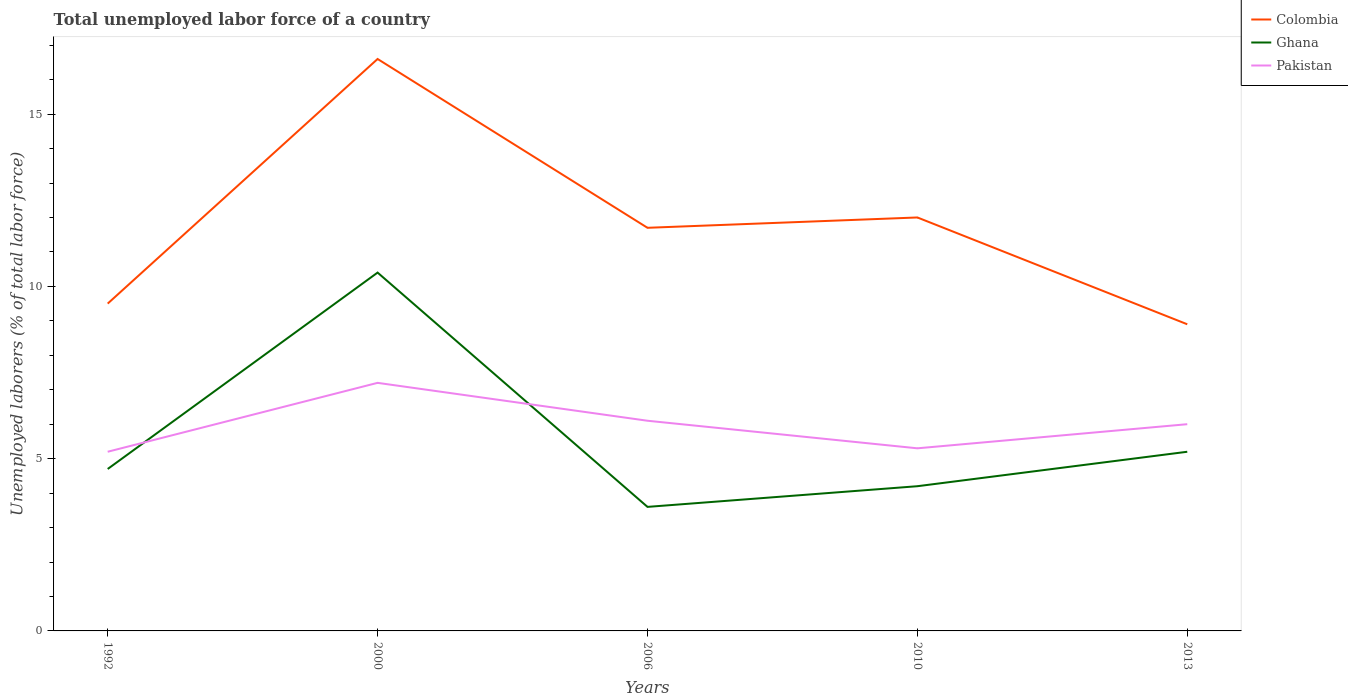How many different coloured lines are there?
Your answer should be compact. 3. Across all years, what is the maximum total unemployed labor force in Ghana?
Provide a succinct answer. 3.6. In which year was the total unemployed labor force in Pakistan maximum?
Offer a very short reply. 1992. What is the total total unemployed labor force in Colombia in the graph?
Keep it short and to the point. 7.7. What is the difference between the highest and the second highest total unemployed labor force in Ghana?
Ensure brevity in your answer.  6.8. Is the total unemployed labor force in Pakistan strictly greater than the total unemployed labor force in Colombia over the years?
Make the answer very short. Yes. How many lines are there?
Provide a succinct answer. 3. How many legend labels are there?
Your answer should be very brief. 3. How are the legend labels stacked?
Provide a short and direct response. Vertical. What is the title of the graph?
Ensure brevity in your answer.  Total unemployed labor force of a country. Does "West Bank and Gaza" appear as one of the legend labels in the graph?
Ensure brevity in your answer.  No. What is the label or title of the Y-axis?
Give a very brief answer. Unemployed laborers (% of total labor force). What is the Unemployed laborers (% of total labor force) of Colombia in 1992?
Provide a succinct answer. 9.5. What is the Unemployed laborers (% of total labor force) in Ghana in 1992?
Your answer should be compact. 4.7. What is the Unemployed laborers (% of total labor force) in Pakistan in 1992?
Offer a very short reply. 5.2. What is the Unemployed laborers (% of total labor force) of Colombia in 2000?
Your answer should be very brief. 16.6. What is the Unemployed laborers (% of total labor force) of Ghana in 2000?
Your answer should be very brief. 10.4. What is the Unemployed laborers (% of total labor force) of Pakistan in 2000?
Keep it short and to the point. 7.2. What is the Unemployed laborers (% of total labor force) of Colombia in 2006?
Your answer should be very brief. 11.7. What is the Unemployed laborers (% of total labor force) of Ghana in 2006?
Provide a succinct answer. 3.6. What is the Unemployed laborers (% of total labor force) in Pakistan in 2006?
Keep it short and to the point. 6.1. What is the Unemployed laborers (% of total labor force) in Ghana in 2010?
Your answer should be very brief. 4.2. What is the Unemployed laborers (% of total labor force) in Pakistan in 2010?
Your answer should be very brief. 5.3. What is the Unemployed laborers (% of total labor force) in Colombia in 2013?
Ensure brevity in your answer.  8.9. What is the Unemployed laborers (% of total labor force) of Ghana in 2013?
Keep it short and to the point. 5.2. Across all years, what is the maximum Unemployed laborers (% of total labor force) in Colombia?
Give a very brief answer. 16.6. Across all years, what is the maximum Unemployed laborers (% of total labor force) of Ghana?
Your answer should be very brief. 10.4. Across all years, what is the maximum Unemployed laborers (% of total labor force) in Pakistan?
Your answer should be very brief. 7.2. Across all years, what is the minimum Unemployed laborers (% of total labor force) in Colombia?
Provide a succinct answer. 8.9. Across all years, what is the minimum Unemployed laborers (% of total labor force) of Ghana?
Keep it short and to the point. 3.6. Across all years, what is the minimum Unemployed laborers (% of total labor force) of Pakistan?
Make the answer very short. 5.2. What is the total Unemployed laborers (% of total labor force) in Colombia in the graph?
Your answer should be very brief. 58.7. What is the total Unemployed laborers (% of total labor force) of Ghana in the graph?
Ensure brevity in your answer.  28.1. What is the total Unemployed laborers (% of total labor force) in Pakistan in the graph?
Provide a succinct answer. 29.8. What is the difference between the Unemployed laborers (% of total labor force) of Pakistan in 1992 and that in 2000?
Make the answer very short. -2. What is the difference between the Unemployed laborers (% of total labor force) of Ghana in 1992 and that in 2006?
Give a very brief answer. 1.1. What is the difference between the Unemployed laborers (% of total labor force) in Pakistan in 1992 and that in 2006?
Give a very brief answer. -0.9. What is the difference between the Unemployed laborers (% of total labor force) in Pakistan in 1992 and that in 2013?
Make the answer very short. -0.8. What is the difference between the Unemployed laborers (% of total labor force) of Ghana in 2000 and that in 2006?
Keep it short and to the point. 6.8. What is the difference between the Unemployed laborers (% of total labor force) in Pakistan in 2000 and that in 2006?
Make the answer very short. 1.1. What is the difference between the Unemployed laborers (% of total labor force) in Colombia in 2000 and that in 2010?
Give a very brief answer. 4.6. What is the difference between the Unemployed laborers (% of total labor force) in Ghana in 2000 and that in 2010?
Provide a succinct answer. 6.2. What is the difference between the Unemployed laborers (% of total labor force) of Pakistan in 2000 and that in 2010?
Your response must be concise. 1.9. What is the difference between the Unemployed laborers (% of total labor force) in Colombia in 2000 and that in 2013?
Give a very brief answer. 7.7. What is the difference between the Unemployed laborers (% of total labor force) in Colombia in 2006 and that in 2010?
Offer a terse response. -0.3. What is the difference between the Unemployed laborers (% of total labor force) in Ghana in 2006 and that in 2010?
Make the answer very short. -0.6. What is the difference between the Unemployed laborers (% of total labor force) in Pakistan in 2006 and that in 2010?
Offer a terse response. 0.8. What is the difference between the Unemployed laborers (% of total labor force) of Colombia in 2006 and that in 2013?
Offer a very short reply. 2.8. What is the difference between the Unemployed laborers (% of total labor force) in Ghana in 2006 and that in 2013?
Provide a succinct answer. -1.6. What is the difference between the Unemployed laborers (% of total labor force) in Pakistan in 2006 and that in 2013?
Offer a terse response. 0.1. What is the difference between the Unemployed laborers (% of total labor force) in Ghana in 2010 and that in 2013?
Provide a short and direct response. -1. What is the difference between the Unemployed laborers (% of total labor force) in Colombia in 1992 and the Unemployed laborers (% of total labor force) in Ghana in 2006?
Ensure brevity in your answer.  5.9. What is the difference between the Unemployed laborers (% of total labor force) of Colombia in 1992 and the Unemployed laborers (% of total labor force) of Pakistan in 2006?
Give a very brief answer. 3.4. What is the difference between the Unemployed laborers (% of total labor force) in Ghana in 1992 and the Unemployed laborers (% of total labor force) in Pakistan in 2006?
Make the answer very short. -1.4. What is the difference between the Unemployed laborers (% of total labor force) of Ghana in 1992 and the Unemployed laborers (% of total labor force) of Pakistan in 2010?
Provide a succinct answer. -0.6. What is the difference between the Unemployed laborers (% of total labor force) of Colombia in 1992 and the Unemployed laborers (% of total labor force) of Ghana in 2013?
Your response must be concise. 4.3. What is the difference between the Unemployed laborers (% of total labor force) in Ghana in 2000 and the Unemployed laborers (% of total labor force) in Pakistan in 2006?
Offer a very short reply. 4.3. What is the difference between the Unemployed laborers (% of total labor force) of Colombia in 2000 and the Unemployed laborers (% of total labor force) of Pakistan in 2010?
Your answer should be compact. 11.3. What is the difference between the Unemployed laborers (% of total labor force) in Ghana in 2000 and the Unemployed laborers (% of total labor force) in Pakistan in 2010?
Your answer should be compact. 5.1. What is the difference between the Unemployed laborers (% of total labor force) in Colombia in 2006 and the Unemployed laborers (% of total labor force) in Ghana in 2010?
Your answer should be very brief. 7.5. What is the difference between the Unemployed laborers (% of total labor force) in Colombia in 2006 and the Unemployed laborers (% of total labor force) in Ghana in 2013?
Provide a succinct answer. 6.5. What is the difference between the Unemployed laborers (% of total labor force) in Ghana in 2006 and the Unemployed laborers (% of total labor force) in Pakistan in 2013?
Make the answer very short. -2.4. What is the difference between the Unemployed laborers (% of total labor force) in Colombia in 2010 and the Unemployed laborers (% of total labor force) in Ghana in 2013?
Provide a short and direct response. 6.8. What is the average Unemployed laborers (% of total labor force) of Colombia per year?
Keep it short and to the point. 11.74. What is the average Unemployed laborers (% of total labor force) of Ghana per year?
Make the answer very short. 5.62. What is the average Unemployed laborers (% of total labor force) in Pakistan per year?
Make the answer very short. 5.96. In the year 1992, what is the difference between the Unemployed laborers (% of total labor force) of Colombia and Unemployed laborers (% of total labor force) of Pakistan?
Offer a terse response. 4.3. In the year 2000, what is the difference between the Unemployed laborers (% of total labor force) of Colombia and Unemployed laborers (% of total labor force) of Ghana?
Make the answer very short. 6.2. In the year 2000, what is the difference between the Unemployed laborers (% of total labor force) in Ghana and Unemployed laborers (% of total labor force) in Pakistan?
Provide a succinct answer. 3.2. In the year 2006, what is the difference between the Unemployed laborers (% of total labor force) of Colombia and Unemployed laborers (% of total labor force) of Ghana?
Your response must be concise. 8.1. In the year 2006, what is the difference between the Unemployed laborers (% of total labor force) in Colombia and Unemployed laborers (% of total labor force) in Pakistan?
Your response must be concise. 5.6. In the year 2010, what is the difference between the Unemployed laborers (% of total labor force) in Colombia and Unemployed laborers (% of total labor force) in Ghana?
Your answer should be very brief. 7.8. In the year 2010, what is the difference between the Unemployed laborers (% of total labor force) of Ghana and Unemployed laborers (% of total labor force) of Pakistan?
Your answer should be very brief. -1.1. In the year 2013, what is the difference between the Unemployed laborers (% of total labor force) of Ghana and Unemployed laborers (% of total labor force) of Pakistan?
Offer a very short reply. -0.8. What is the ratio of the Unemployed laborers (% of total labor force) in Colombia in 1992 to that in 2000?
Your answer should be very brief. 0.57. What is the ratio of the Unemployed laborers (% of total labor force) in Ghana in 1992 to that in 2000?
Give a very brief answer. 0.45. What is the ratio of the Unemployed laborers (% of total labor force) of Pakistan in 1992 to that in 2000?
Make the answer very short. 0.72. What is the ratio of the Unemployed laborers (% of total labor force) of Colombia in 1992 to that in 2006?
Your answer should be compact. 0.81. What is the ratio of the Unemployed laborers (% of total labor force) in Ghana in 1992 to that in 2006?
Your response must be concise. 1.31. What is the ratio of the Unemployed laborers (% of total labor force) in Pakistan in 1992 to that in 2006?
Keep it short and to the point. 0.85. What is the ratio of the Unemployed laborers (% of total labor force) in Colombia in 1992 to that in 2010?
Give a very brief answer. 0.79. What is the ratio of the Unemployed laborers (% of total labor force) of Ghana in 1992 to that in 2010?
Make the answer very short. 1.12. What is the ratio of the Unemployed laborers (% of total labor force) of Pakistan in 1992 to that in 2010?
Provide a short and direct response. 0.98. What is the ratio of the Unemployed laborers (% of total labor force) of Colombia in 1992 to that in 2013?
Your answer should be very brief. 1.07. What is the ratio of the Unemployed laborers (% of total labor force) of Ghana in 1992 to that in 2013?
Make the answer very short. 0.9. What is the ratio of the Unemployed laborers (% of total labor force) in Pakistan in 1992 to that in 2013?
Make the answer very short. 0.87. What is the ratio of the Unemployed laborers (% of total labor force) of Colombia in 2000 to that in 2006?
Offer a terse response. 1.42. What is the ratio of the Unemployed laborers (% of total labor force) of Ghana in 2000 to that in 2006?
Keep it short and to the point. 2.89. What is the ratio of the Unemployed laborers (% of total labor force) in Pakistan in 2000 to that in 2006?
Provide a short and direct response. 1.18. What is the ratio of the Unemployed laborers (% of total labor force) of Colombia in 2000 to that in 2010?
Keep it short and to the point. 1.38. What is the ratio of the Unemployed laborers (% of total labor force) in Ghana in 2000 to that in 2010?
Offer a terse response. 2.48. What is the ratio of the Unemployed laborers (% of total labor force) of Pakistan in 2000 to that in 2010?
Offer a very short reply. 1.36. What is the ratio of the Unemployed laborers (% of total labor force) of Colombia in 2000 to that in 2013?
Offer a terse response. 1.87. What is the ratio of the Unemployed laborers (% of total labor force) of Pakistan in 2000 to that in 2013?
Your answer should be compact. 1.2. What is the ratio of the Unemployed laborers (% of total labor force) of Colombia in 2006 to that in 2010?
Your answer should be very brief. 0.97. What is the ratio of the Unemployed laborers (% of total labor force) of Pakistan in 2006 to that in 2010?
Your answer should be compact. 1.15. What is the ratio of the Unemployed laborers (% of total labor force) of Colombia in 2006 to that in 2013?
Your response must be concise. 1.31. What is the ratio of the Unemployed laborers (% of total labor force) of Ghana in 2006 to that in 2013?
Give a very brief answer. 0.69. What is the ratio of the Unemployed laborers (% of total labor force) of Pakistan in 2006 to that in 2013?
Your answer should be compact. 1.02. What is the ratio of the Unemployed laborers (% of total labor force) in Colombia in 2010 to that in 2013?
Offer a very short reply. 1.35. What is the ratio of the Unemployed laborers (% of total labor force) in Ghana in 2010 to that in 2013?
Offer a terse response. 0.81. What is the ratio of the Unemployed laborers (% of total labor force) in Pakistan in 2010 to that in 2013?
Provide a succinct answer. 0.88. What is the difference between the highest and the second highest Unemployed laborers (% of total labor force) in Colombia?
Offer a very short reply. 4.6. What is the difference between the highest and the second highest Unemployed laborers (% of total labor force) in Pakistan?
Your answer should be very brief. 1.1. What is the difference between the highest and the lowest Unemployed laborers (% of total labor force) of Colombia?
Your answer should be very brief. 7.7. What is the difference between the highest and the lowest Unemployed laborers (% of total labor force) of Pakistan?
Offer a very short reply. 2. 